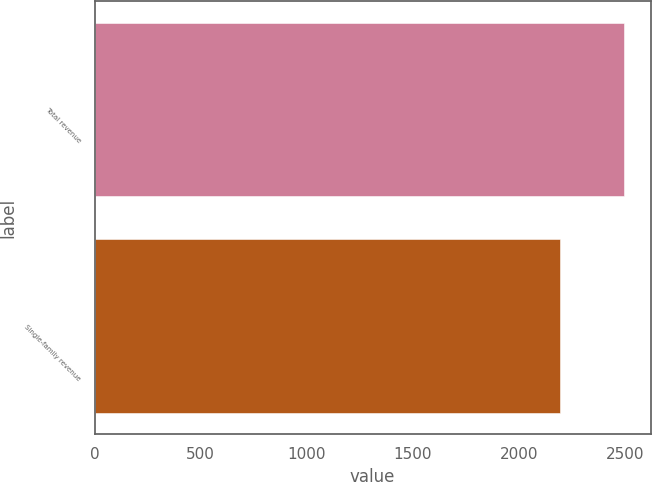<chart> <loc_0><loc_0><loc_500><loc_500><bar_chart><fcel>Total revenue<fcel>Single-family revenue<nl><fcel>2495<fcel>2193<nl></chart> 